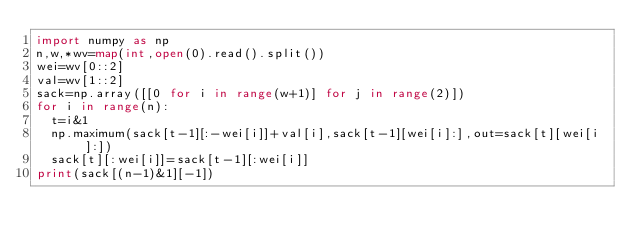<code> <loc_0><loc_0><loc_500><loc_500><_Python_>import numpy as np
n,w,*wv=map(int,open(0).read().split())
wei=wv[0::2]
val=wv[1::2]
sack=np.array([[0 for i in range(w+1)] for j in range(2)])
for i in range(n):
  t=i&1
  np.maximum(sack[t-1][:-wei[i]]+val[i],sack[t-1][wei[i]:],out=sack[t][wei[i]:])
  sack[t][:wei[i]]=sack[t-1][:wei[i]]
print(sack[(n-1)&1][-1])</code> 